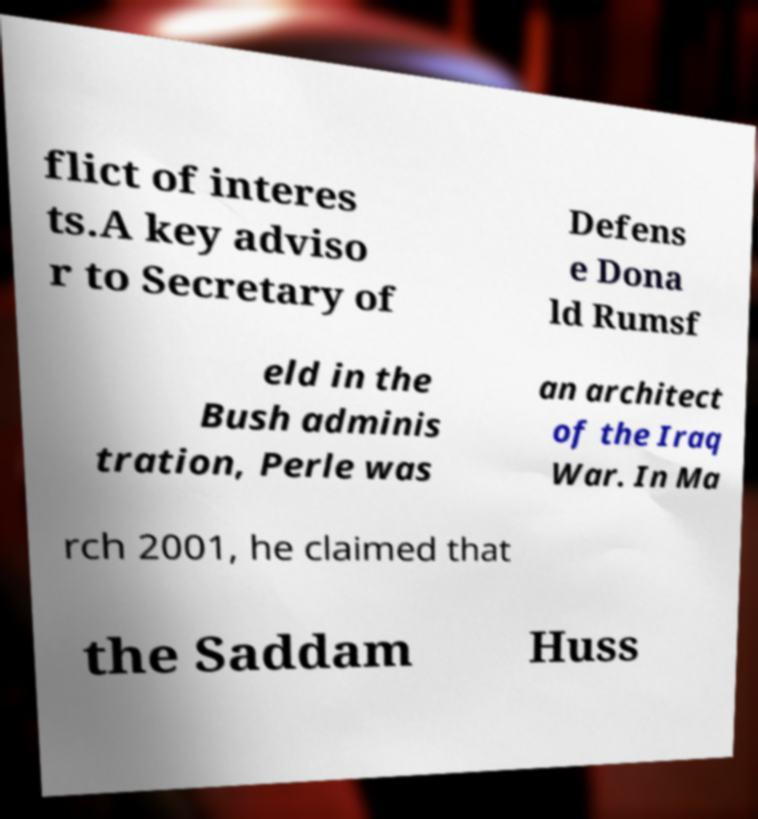Could you assist in decoding the text presented in this image and type it out clearly? flict of interes ts.A key adviso r to Secretary of Defens e Dona ld Rumsf eld in the Bush adminis tration, Perle was an architect of the Iraq War. In Ma rch 2001, he claimed that the Saddam Huss 